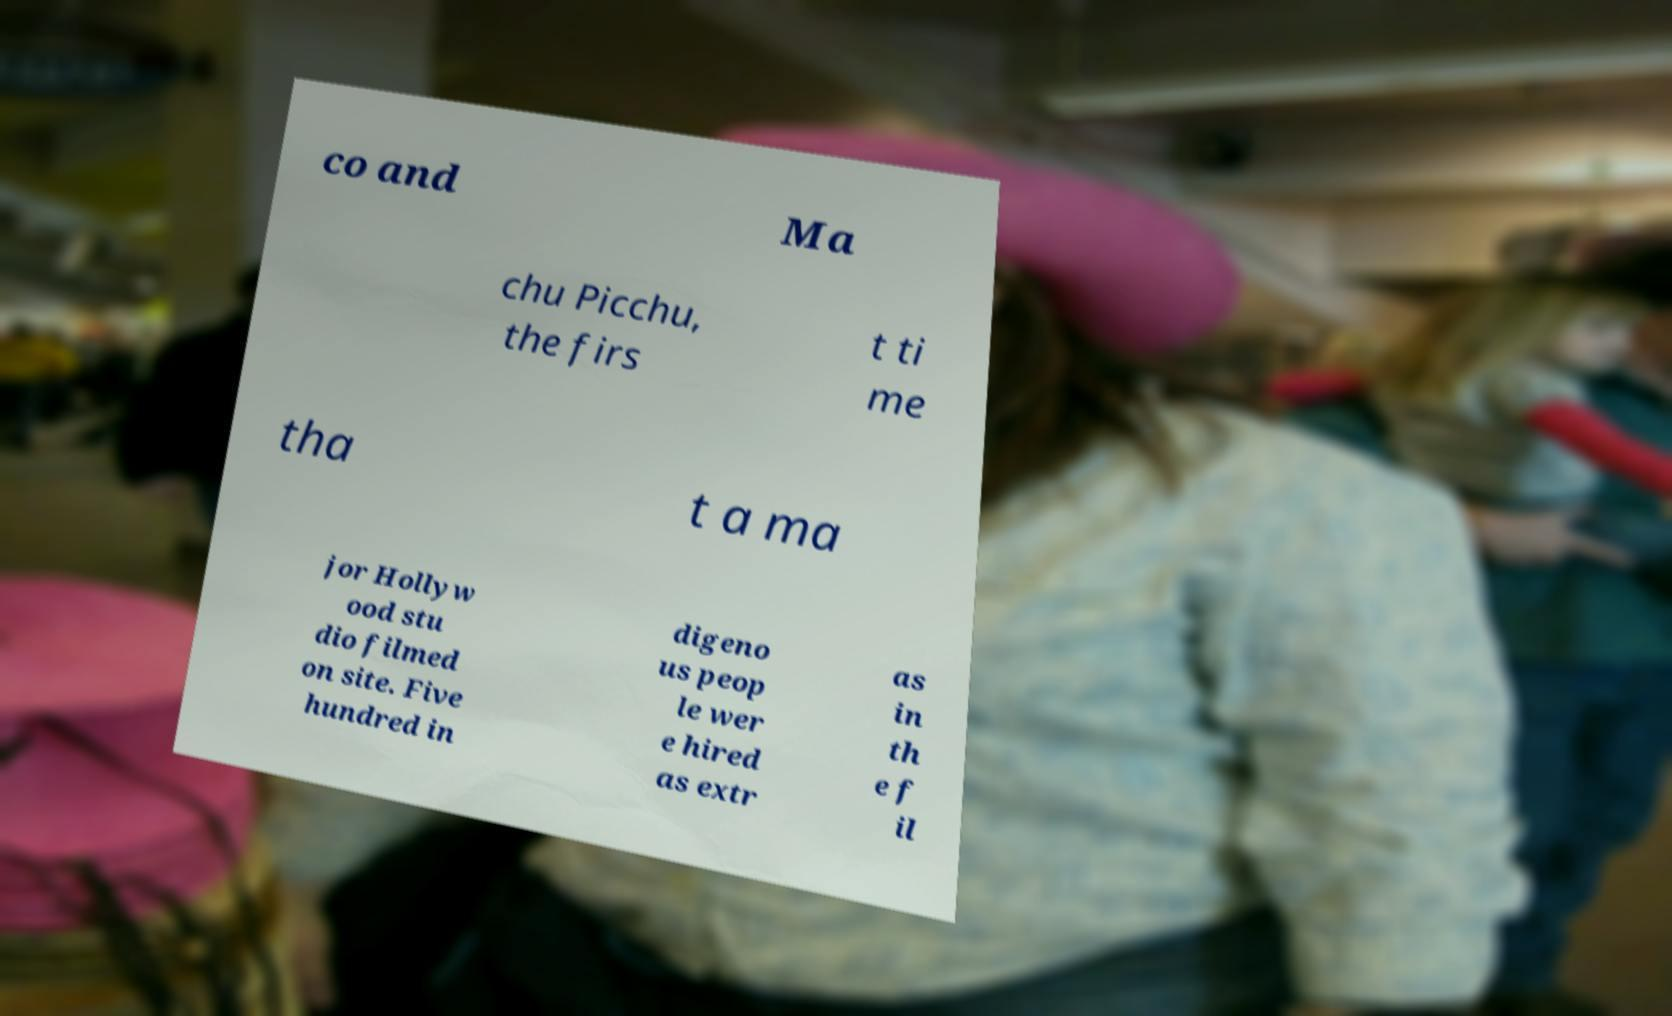What messages or text are displayed in this image? I need them in a readable, typed format. co and Ma chu Picchu, the firs t ti me tha t a ma jor Hollyw ood stu dio filmed on site. Five hundred in digeno us peop le wer e hired as extr as in th e f il 